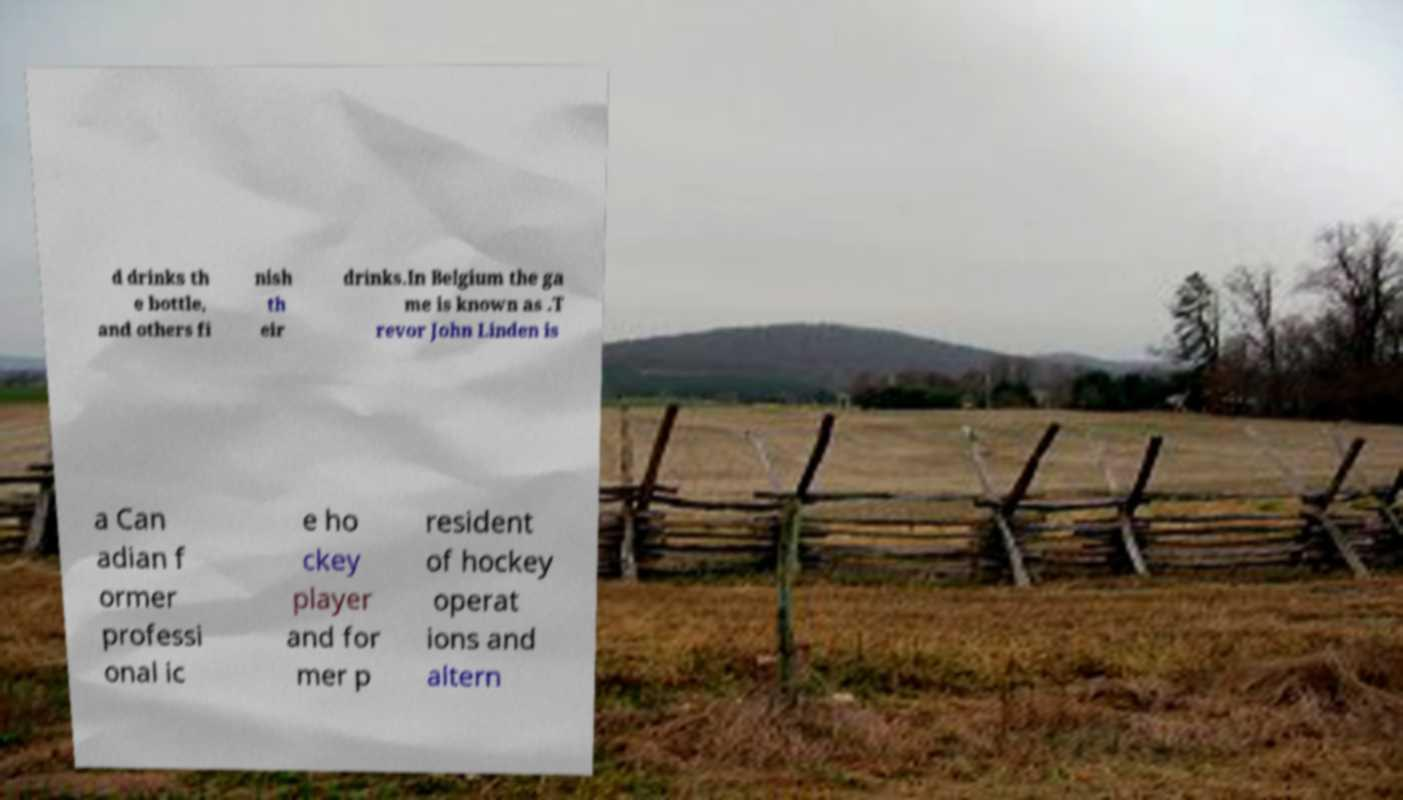What messages or text are displayed in this image? I need them in a readable, typed format. d drinks th e bottle, and others fi nish th eir drinks.In Belgium the ga me is known as .T revor John Linden is a Can adian f ormer professi onal ic e ho ckey player and for mer p resident of hockey operat ions and altern 